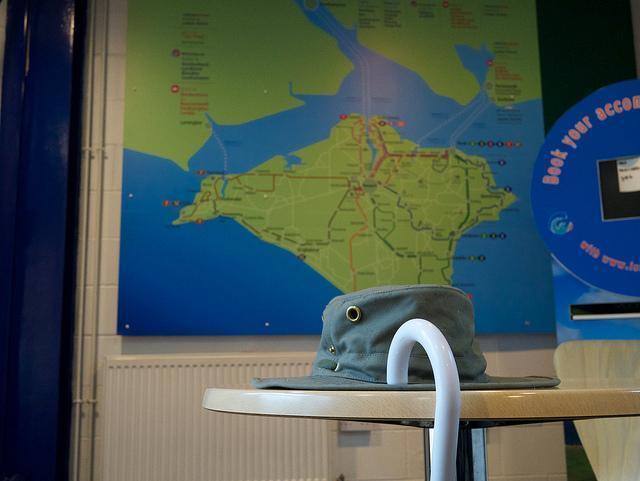How many chairs can you see?
Give a very brief answer. 1. 